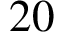<formula> <loc_0><loc_0><loc_500><loc_500>2 0</formula> 